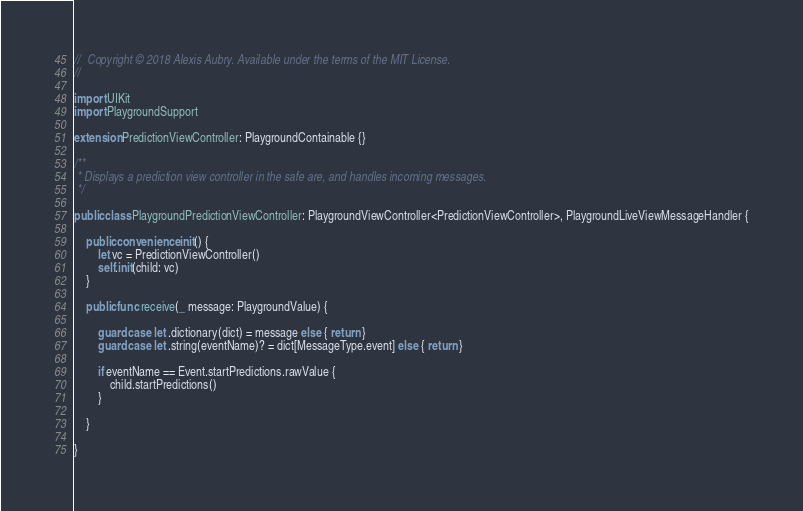Convert code to text. <code><loc_0><loc_0><loc_500><loc_500><_Swift_>//  Copyright © 2018 Alexis Aubry. Available under the terms of the MIT License.
//

import UIKit
import PlaygroundSupport

extension PredictionViewController: PlaygroundContainable {}

/**
 * Displays a prediction view controller in the safe are, and handles incoming messages.
 */

public class PlaygroundPredictionViewController: PlaygroundViewController<PredictionViewController>, PlaygroundLiveViewMessageHandler {

    public convenience init() {
        let vc = PredictionViewController()
        self.init(child: vc)
    }

    public func receive(_ message: PlaygroundValue) {

        guard case let .dictionary(dict) = message else { return }
        guard case let .string(eventName)? = dict[MessageType.event] else { return }

        if eventName == Event.startPredictions.rawValue {
            child.startPredictions()
        }

    }

}
</code> 